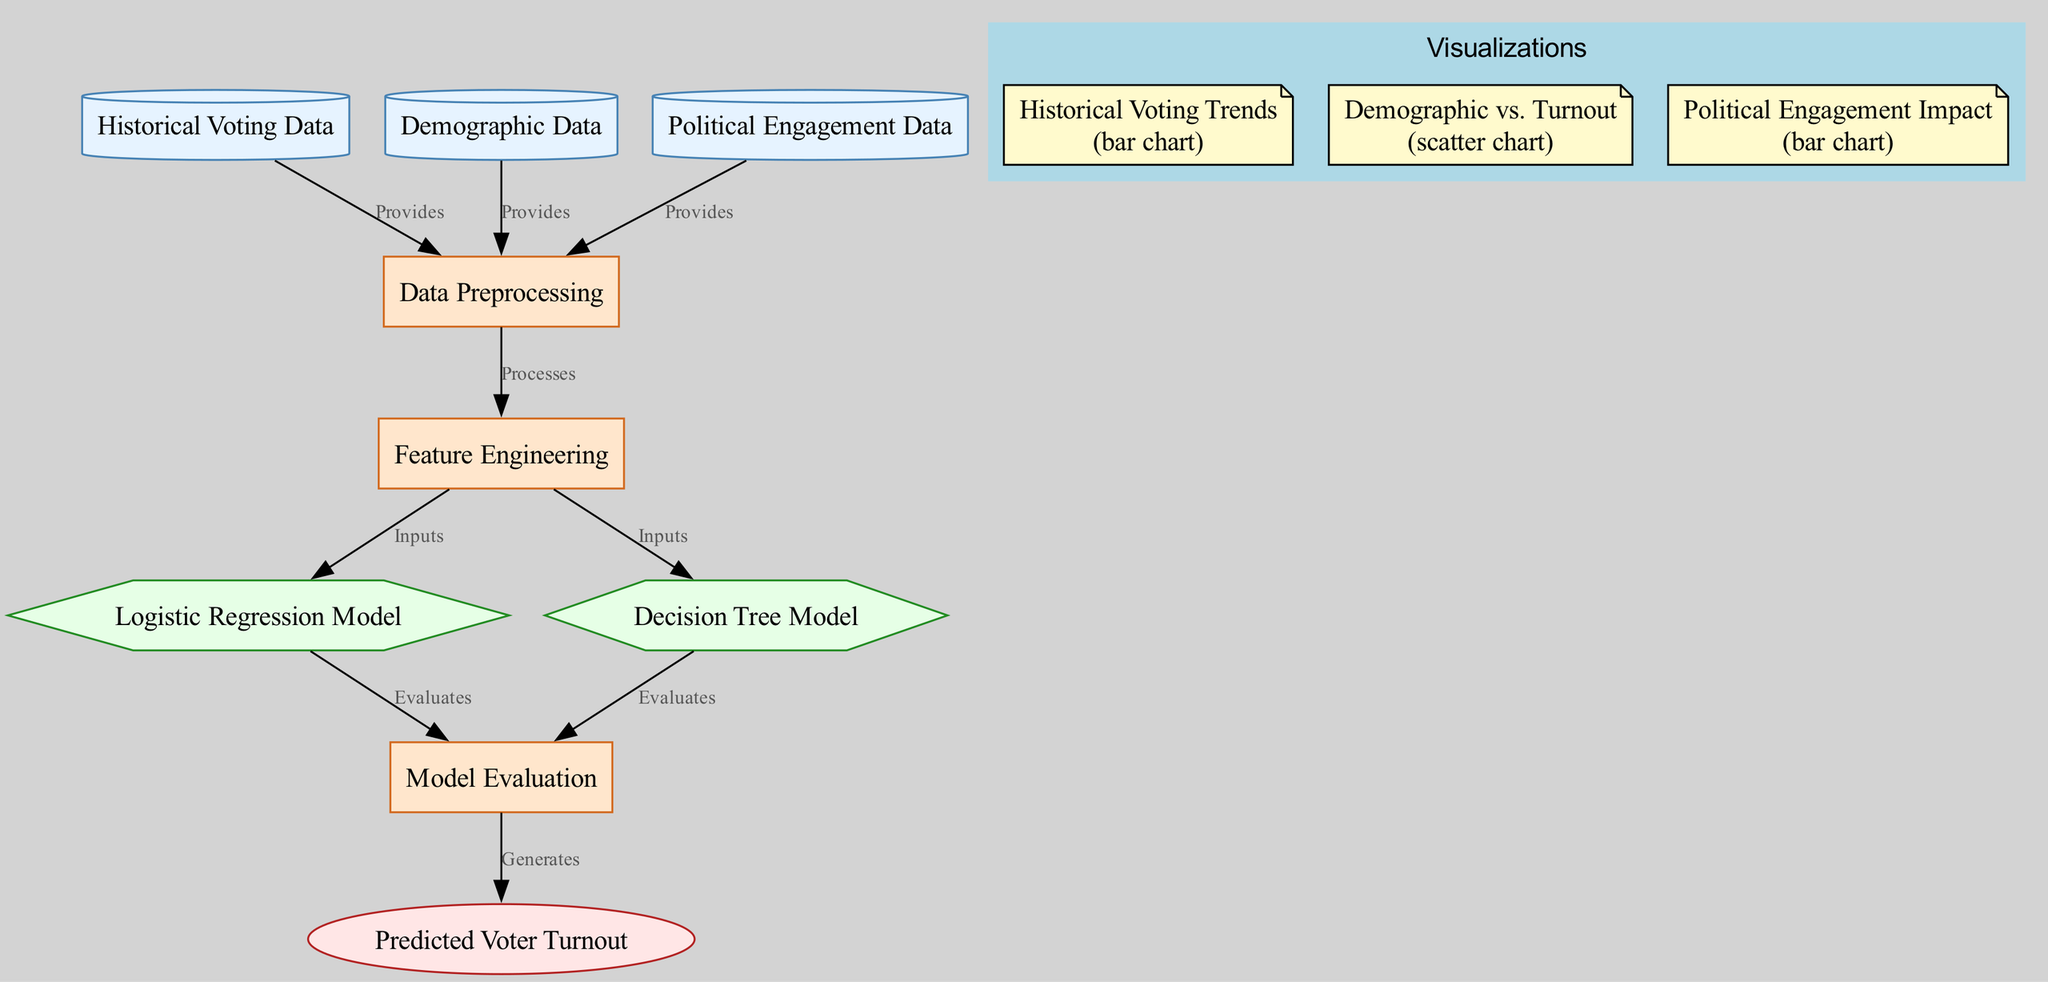What types of data are used in the model? The model utilizes three main types of data: Historical Voting Data, Demographic Data, and Political Engagement Data, as each of these nodes is labeled accordingly in the diagram.
Answer: Historical Voting Data, Demographic Data, Political Engagement Data How many processes are involved in this model? The diagram indicates there are four processes: Data Preprocessing, Feature Engineering, Model Evaluation, and there are two different models (Logistic Regression and Decision Tree) evaluated, resulting in a total of four processes.
Answer: Four What is the final output of the model? The final output node in the diagram is labeled Predicted Voter Turnout, which represents the overall result of the predictive analysis processes described.
Answer: Predicted Voter Turnout Which model evaluates inputs from Feature Engineering? Both Logistic Regression Model and Decision Tree Model receive inputs from the Feature Engineering node, but since the question asks for one specific model, either one suffices.
Answer: Logistic Regression Model or Decision Tree Model What type of chart visualizes the relationship between Demographic Data and Predicted Voter Turnout? The diagram indicates that a scatter chart visualizes the correlation between Demographic Data and the predicted voter turnout outcomes, as clearly stated in the visualizations section.
Answer: Scatter Which process follows Data Preprocessing in the flow? After Data Preprocessing in the diagram, the next step is Feature Engineering, which processes the data to enhance the predictive capabilities of the models used.
Answer: Feature Engineering What provides inputs to the Model Evaluation? The Model Evaluation process receives inputs from both the Logistic Regression Model and the Decision Tree Model, as indicated by their respective connections in the diagram.
Answer: Logistic Regression Model and Decision Tree Model Which visualization shows the impact of Political Engagement? The diagram shows that the bar chart labeled Political Engagement Impact visualizes how political engagement data affects voter turnout predictions.
Answer: Political Engagement Impact What are the shapes of the data nodes? The data nodes are represented using the shape of a cylinder, according to the diagram's styling for different node types.
Answer: Cylinder 